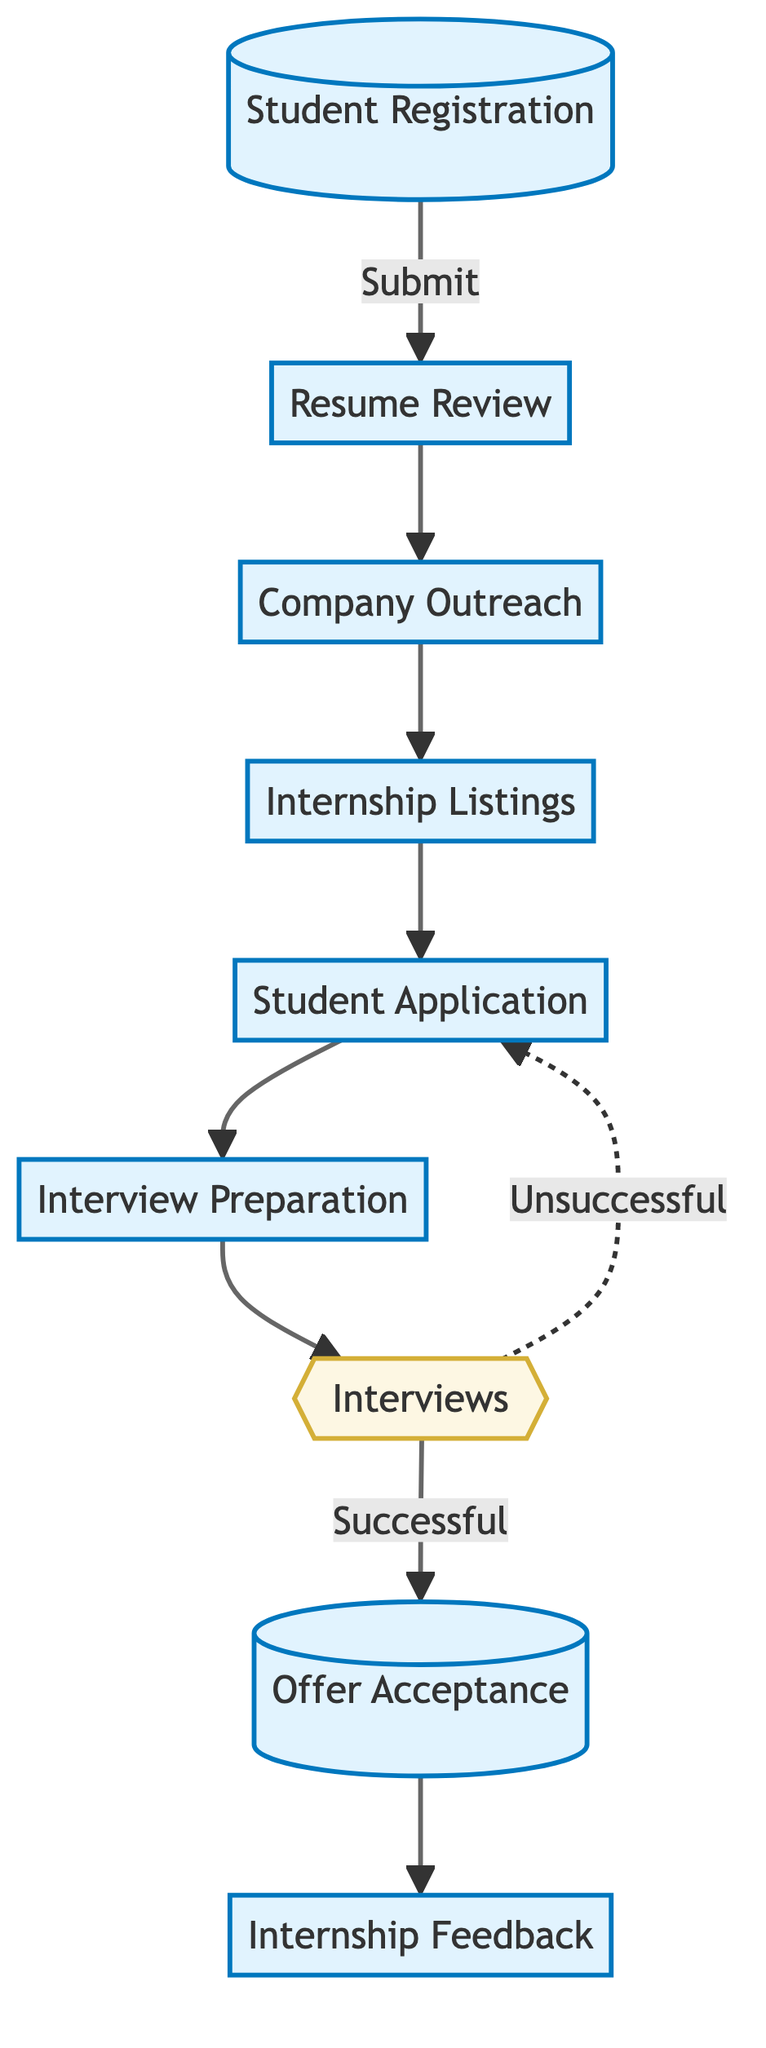What is the first step in the internship placement process? The first step in the process is "Student Registration," where students fill out an online form to express their interest in summer internships.
Answer: Student Registration How many main steps are there in the internship placement process? The diagram shows a total of nine distinct elements or steps involved in the placement process.
Answer: Nine What action follows "Resume Review"? After "Resume Review," the next action in the flow is "Company Outreach," where potential companies are contacted to gather internship opportunities.
Answer: Company Outreach What happens if a student is unsuccessful in the interview? If a student is unsuccessful in the interview, the flow indicates that they return to "Student Application" to apply for different internships.
Answer: Student Application Which step comes directly after "Internship Listings"? The step that follows directly after "Internship Listings" is "Student Application," where students apply for the internships listed.
Answer: Student Application What kind of step is "Interviews"? "Interviews" is a decision point in the process, as it determines whether students are successful or unsuccessful in securing an internship.
Answer: Decision What is collected after the internships are completed? After the internships, "Internship Feedback" is collected from both students and companies to evaluate the overall experience.
Answer: Internship Feedback How do students demonstrate their interest in internships? Students show their interest in internships by filling out an online form during the "Student Registration" step.
Answer: Online form What is the outcome if students accept offers? If students accept offers, it leads to the "Internship Feedback" step, where evaluations take place after the internship period.
Answer: Internship Feedback 